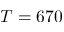<formula> <loc_0><loc_0><loc_500><loc_500>T = 6 7 0</formula> 